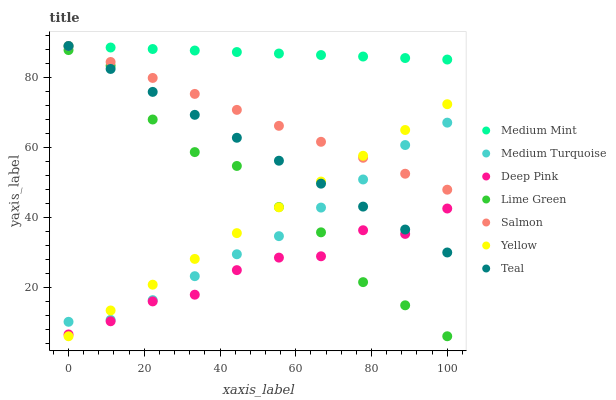Does Deep Pink have the minimum area under the curve?
Answer yes or no. Yes. Does Medium Mint have the maximum area under the curve?
Answer yes or no. Yes. Does Teal have the minimum area under the curve?
Answer yes or no. No. Does Teal have the maximum area under the curve?
Answer yes or no. No. Is Yellow the smoothest?
Answer yes or no. Yes. Is Lime Green the roughest?
Answer yes or no. Yes. Is Deep Pink the smoothest?
Answer yes or no. No. Is Deep Pink the roughest?
Answer yes or no. No. Does Yellow have the lowest value?
Answer yes or no. Yes. Does Deep Pink have the lowest value?
Answer yes or no. No. Does Salmon have the highest value?
Answer yes or no. Yes. Does Deep Pink have the highest value?
Answer yes or no. No. Is Deep Pink less than Medium Turquoise?
Answer yes or no. Yes. Is Medium Mint greater than Deep Pink?
Answer yes or no. Yes. Does Medium Turquoise intersect Lime Green?
Answer yes or no. Yes. Is Medium Turquoise less than Lime Green?
Answer yes or no. No. Is Medium Turquoise greater than Lime Green?
Answer yes or no. No. Does Deep Pink intersect Medium Turquoise?
Answer yes or no. No. 